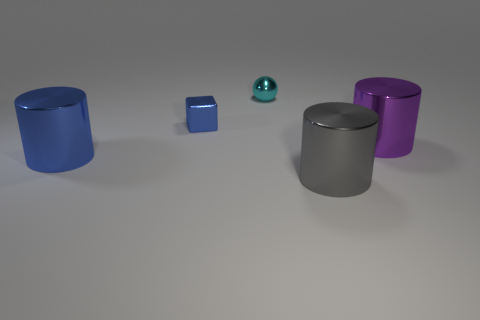Are the small cube and the large thing that is behind the big blue shiny object made of the same material?
Provide a succinct answer. Yes. The large thing in front of the cylinder that is left of the blue object that is behind the big purple cylinder is what color?
Ensure brevity in your answer.  Gray. There is a blue thing that is the same size as the gray thing; what material is it?
Offer a terse response. Metal. What number of small blue cubes have the same material as the big purple cylinder?
Keep it short and to the point. 1. Is the size of the metallic cylinder on the left side of the tiny ball the same as the metallic object that is on the right side of the gray cylinder?
Keep it short and to the point. Yes. The big metallic cylinder on the right side of the gray metal object is what color?
Your answer should be compact. Purple. There is a big thing that is the same color as the metal cube; what is its material?
Provide a succinct answer. Metal. What number of cylinders are the same color as the metallic block?
Offer a very short reply. 1. Does the purple metallic cylinder have the same size as the thing that is behind the tiny blue cube?
Offer a terse response. No. What size is the shiny cylinder on the right side of the gray shiny object that is to the right of the cyan thing that is behind the tiny blue metal thing?
Make the answer very short. Large. 